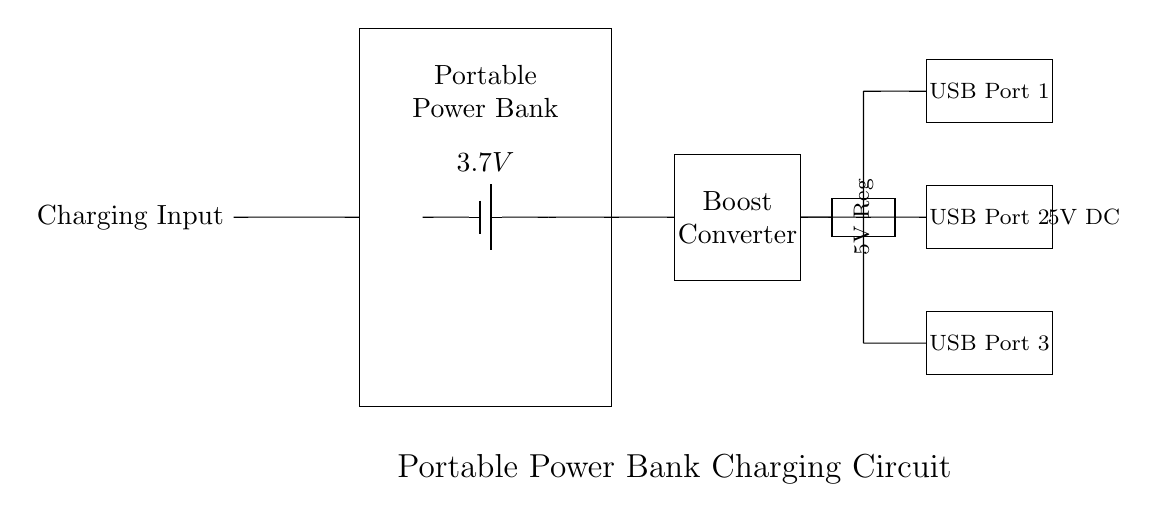What is the input voltage required for charging? The input voltage for charging is not directly visible on the circuit diagram but can be inferred from the standard voltages used in USB devices and power banks. Typically, a charging input for a portable power bank takes a USB input of 5V.
Answer: 5V How many USB ports are available? The circuit diagram shows three distinct rectangular USB port symbols, indicating the physical output connectors. Each rectangle represents one USB port.
Answer: Three What is the function of the boost converter? The boost converter takes the lower voltage from the battery (3.7V) and steps it up to a higher voltage (5V) suitable for USB charging, ensuring devices receive the correct voltage.
Answer: Voltage step-up What is the output voltage of this circuit? The output voltage is indicated on the circuit diagram as 5V DC, which is provided at the USB ports for charging devices.
Answer: 5V DC What is the role of the voltage regulator? The voltage regulator's role is to stabilize the output voltage at 5V, ensuring that even if the battery voltage drops, the output remains constant for safe device charging.
Answer: Stabilization Which component charges the battery? The charging input, which is connected to an external power source, is responsible for charging the battery within the power bank. This input allows the battery to be replenished when not in use.
Answer: Charging Input What does the rectangle labeled "Portable Power Bank" represent? The rectangle labeled "Portable Power Bank" denotes the housing or device containing the battery and circuitry responsible for energy storage and conversion to output for charging other devices.
Answer: Power Bank 